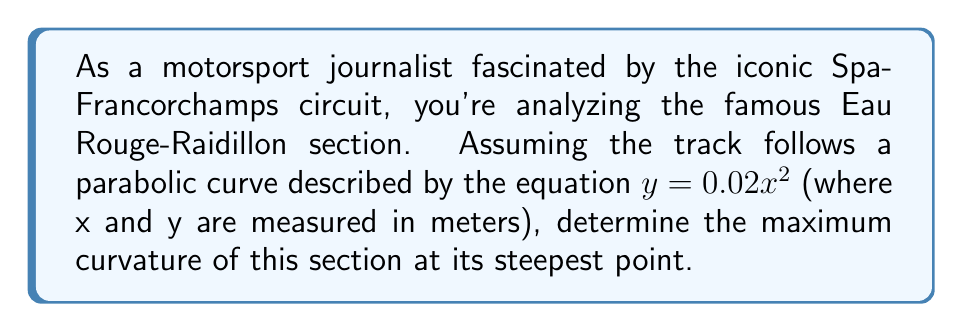Can you answer this question? To find the maximum curvature of the Eau Rouge-Raidillon section, we'll follow these steps:

1) The formula for curvature $\kappa$ of a function $y=f(x)$ is:

   $$\kappa = \frac{|f''(x)|}{(1+[f'(x)]^2)^{3/2}}$$

2) For our parabola $y = 0.02x^2$, we need to find $f'(x)$ and $f''(x)$:
   
   $f'(x) = 0.04x$
   $f''(x) = 0.04$

3) Substituting these into the curvature formula:

   $$\kappa = \frac{|0.04|}{(1+[0.04x]^2)^{3/2}}$$

4) The maximum curvature will occur at the steepest point of the parabola, which is at its vertex (x = 0). At this point:

   $$\kappa_{max} = \frac{0.04}{(1+0^2)^{3/2}} = 0.04 \text{ m}^{-1}$$

5) Converting to more practical units for a racetrack, we can express this as:

   $$\kappa_{max} = 40 \text{ km}^{-1}$$

This means at its steepest point, the Eau Rouge-Raidillon section has a radius of curvature of 25 meters, highlighting the extreme challenge this corner presents to drivers like Robert Kubica.
Answer: $40 \text{ km}^{-1}$ 